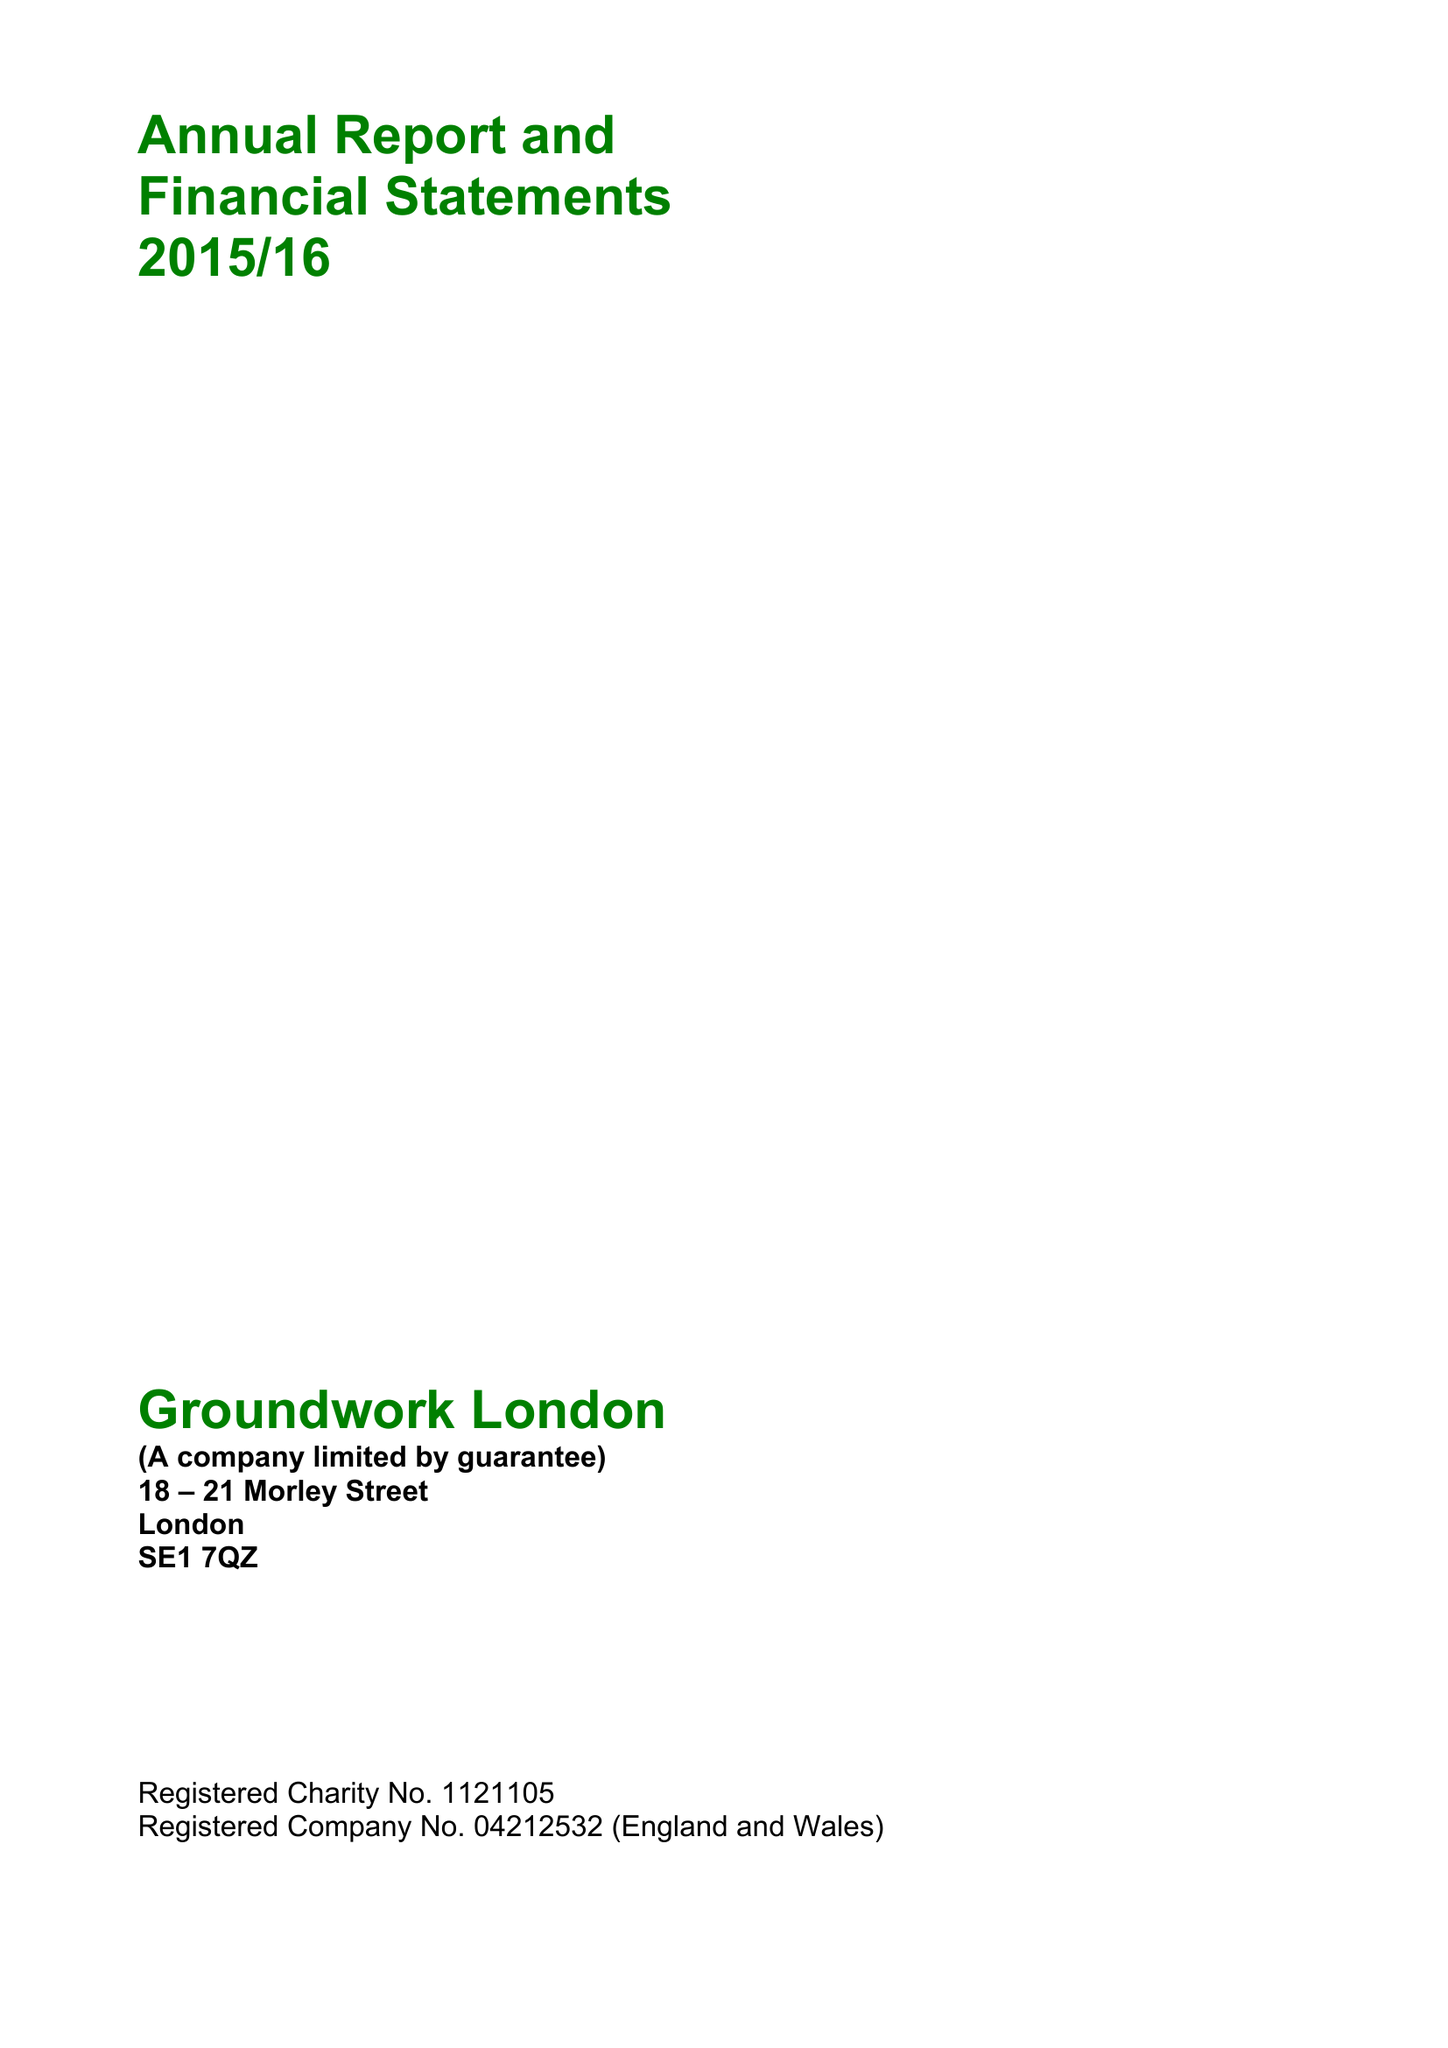What is the value for the spending_annually_in_british_pounds?
Answer the question using a single word or phrase. 11251675.00 